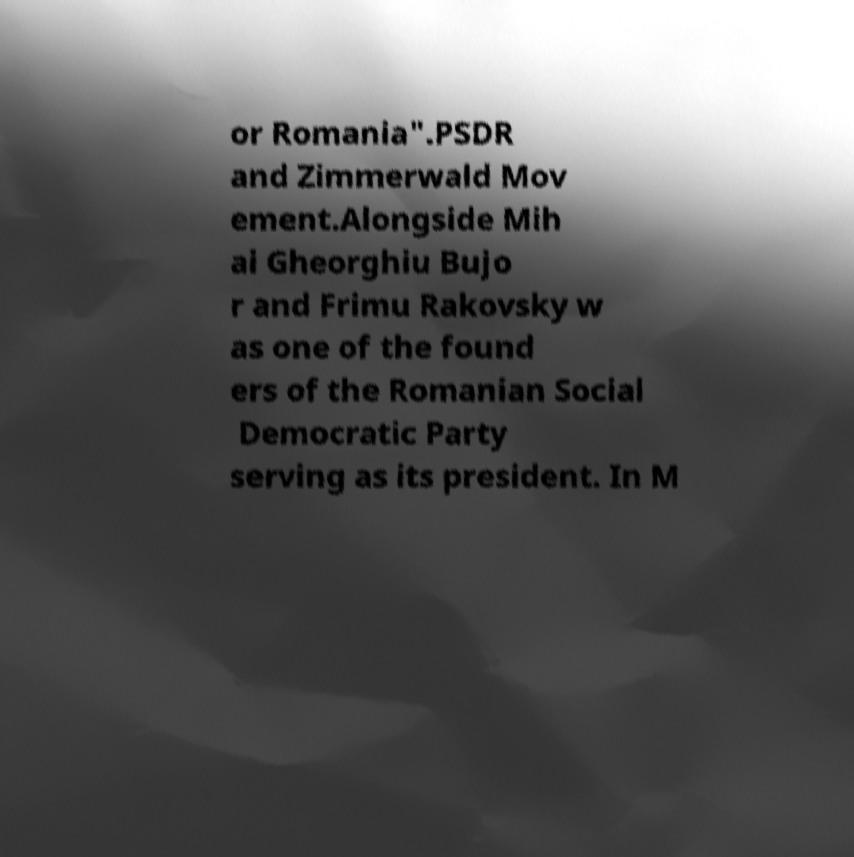Please identify and transcribe the text found in this image. or Romania".PSDR and Zimmerwald Mov ement.Alongside Mih ai Gheorghiu Bujo r and Frimu Rakovsky w as one of the found ers of the Romanian Social Democratic Party serving as its president. In M 